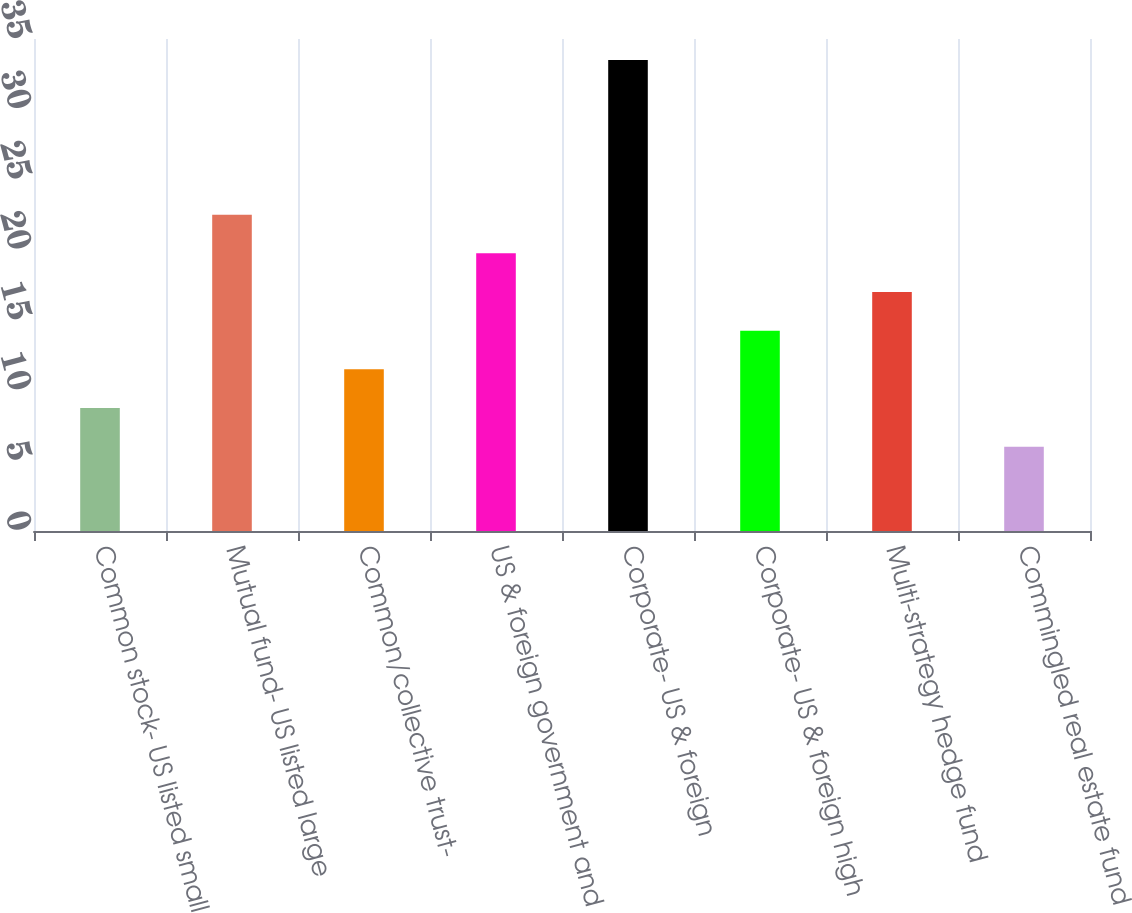Convert chart to OTSL. <chart><loc_0><loc_0><loc_500><loc_500><bar_chart><fcel>Common stock- US listed small<fcel>Mutual fund- US listed large<fcel>Common/collective trust-<fcel>US & foreign government and<fcel>Corporate- US & foreign<fcel>Corporate- US & foreign high<fcel>Multi-strategy hedge fund<fcel>Commingled real estate fund<nl><fcel>8.75<fcel>22.5<fcel>11.5<fcel>19.75<fcel>33.5<fcel>14.25<fcel>17<fcel>6<nl></chart> 